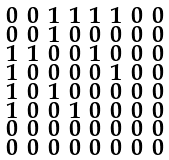Convert formula to latex. <formula><loc_0><loc_0><loc_500><loc_500>\begin{smallmatrix} 0 & 0 & 1 & 1 & 1 & 1 & 0 & 0 \\ 0 & 0 & 1 & 0 & 0 & 0 & 0 & 0 \\ 1 & 1 & 0 & 0 & 1 & 0 & 0 & 0 \\ 1 & 0 & 0 & 0 & 0 & 1 & 0 & 0 \\ 1 & 0 & 1 & 0 & 0 & 0 & 0 & 0 \\ 1 & 0 & 0 & 1 & 0 & 0 & 0 & 0 \\ 0 & 0 & 0 & 0 & 0 & 0 & 0 & 0 \\ 0 & 0 & 0 & 0 & 0 & 0 & 0 & 0 \end{smallmatrix}</formula> 